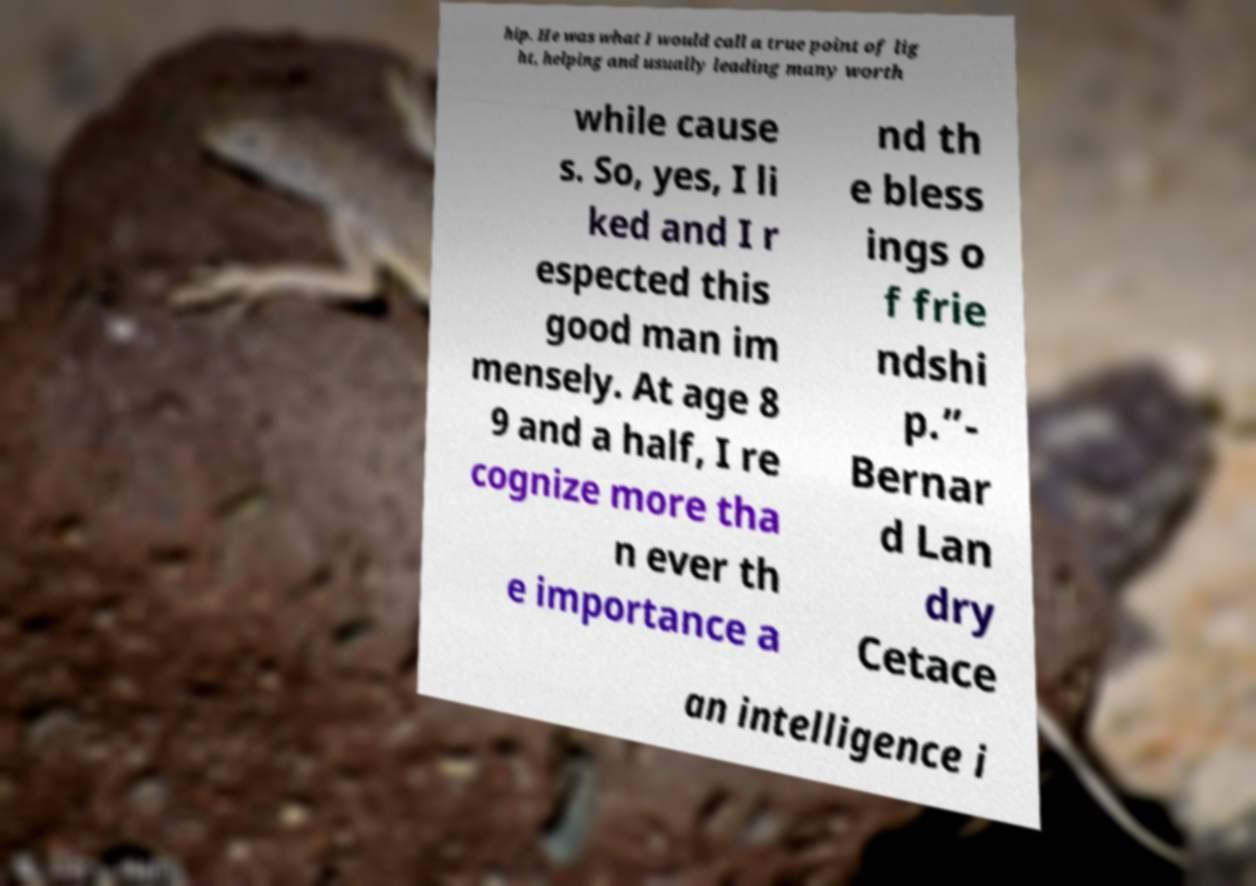Can you read and provide the text displayed in the image?This photo seems to have some interesting text. Can you extract and type it out for me? hip. He was what I would call a true point of lig ht, helping and usually leading many worth while cause s. So, yes, I li ked and I r espected this good man im mensely. At age 8 9 and a half, I re cognize more tha n ever th e importance a nd th e bless ings o f frie ndshi p.”- Bernar d Lan dry Cetace an intelligence i 